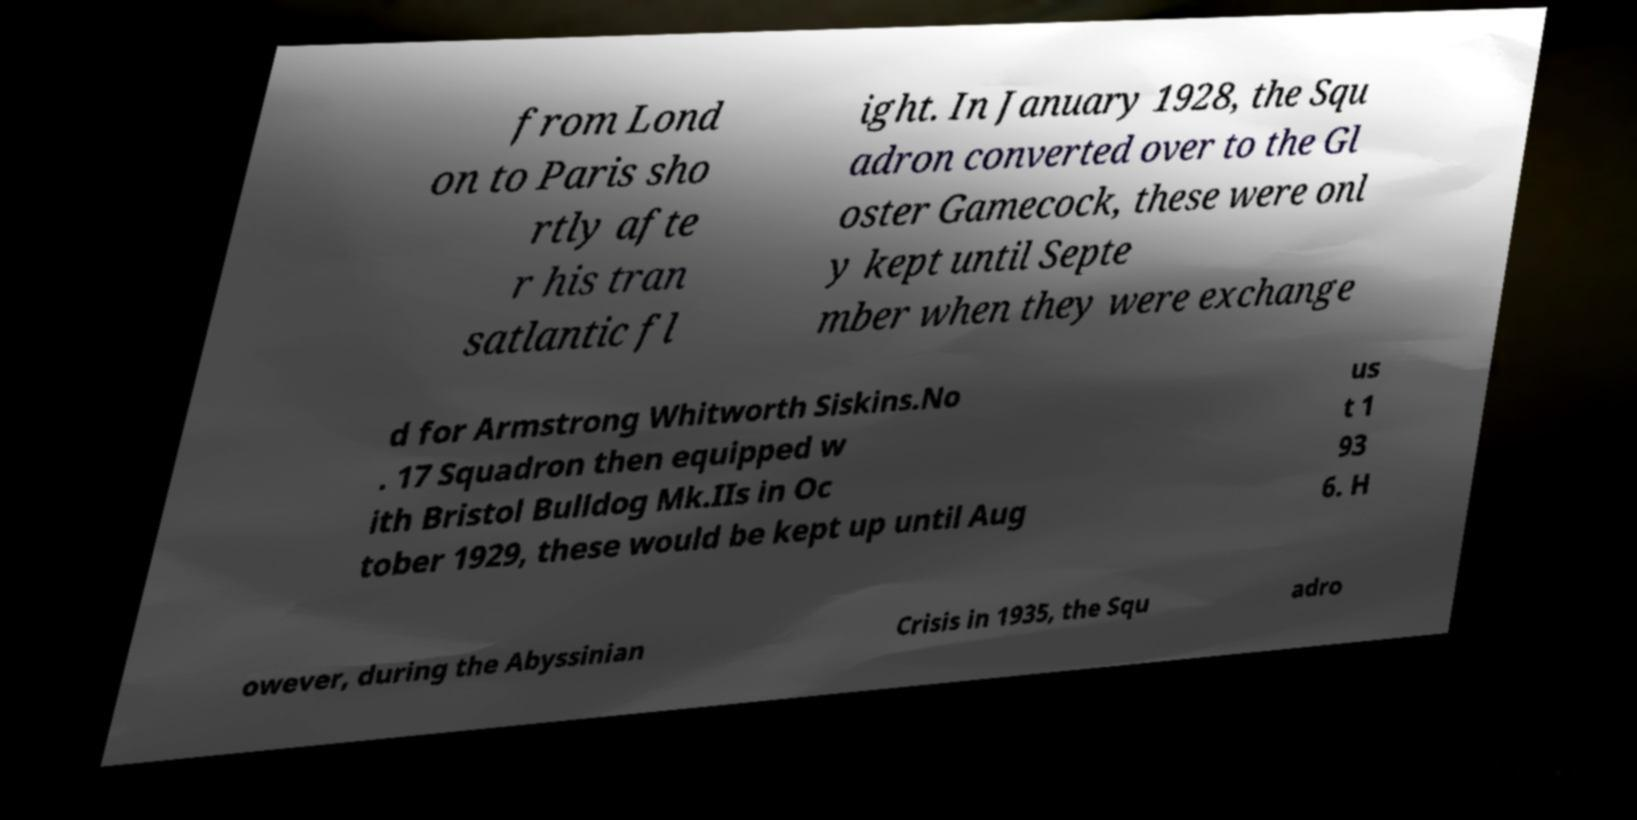Please identify and transcribe the text found in this image. from Lond on to Paris sho rtly afte r his tran satlantic fl ight. In January 1928, the Squ adron converted over to the Gl oster Gamecock, these were onl y kept until Septe mber when they were exchange d for Armstrong Whitworth Siskins.No . 17 Squadron then equipped w ith Bristol Bulldog Mk.IIs in Oc tober 1929, these would be kept up until Aug us t 1 93 6. H owever, during the Abyssinian Crisis in 1935, the Squ adro 